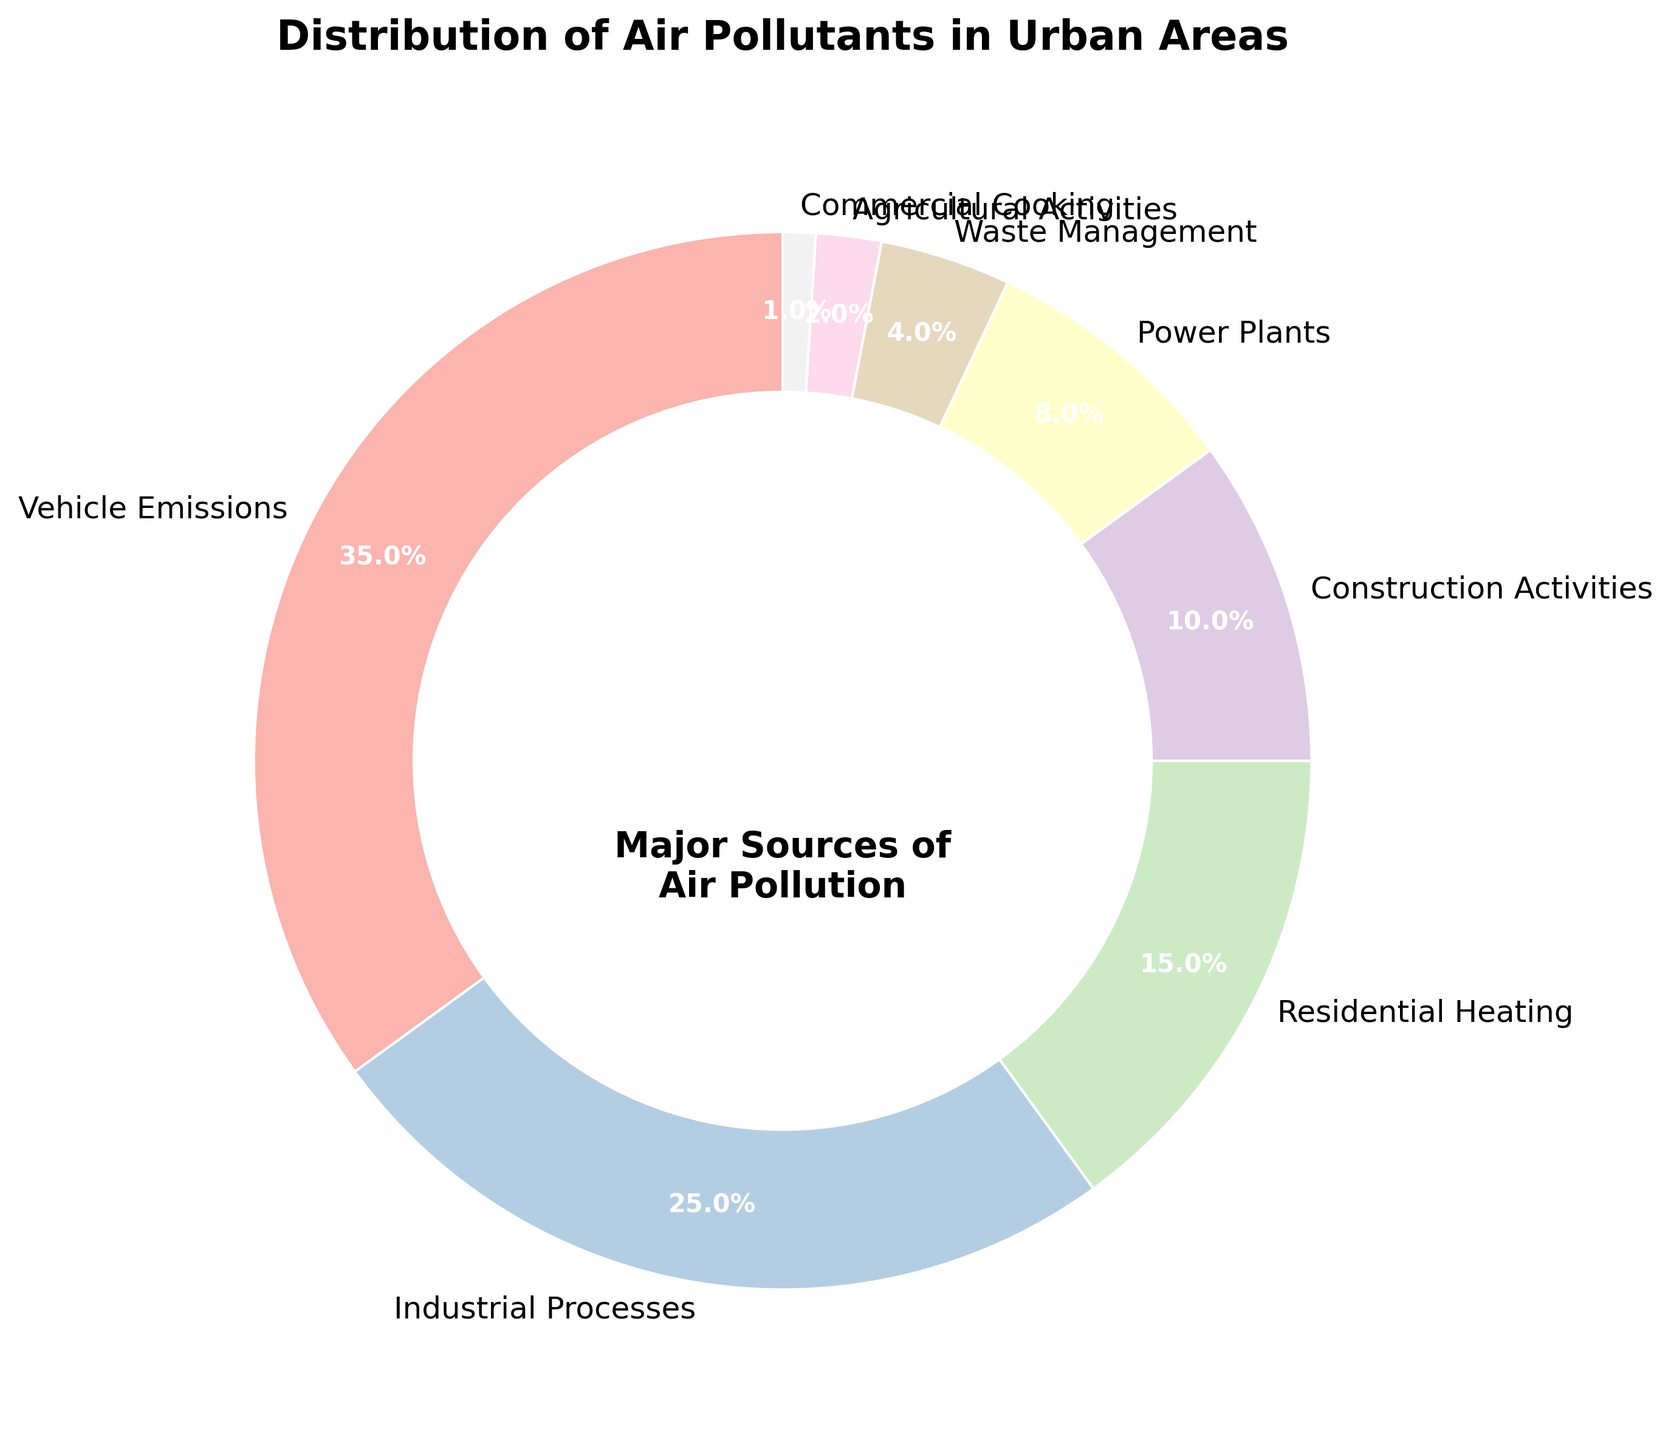Which source contributes the largest percentage to air pollution in urban areas? Observing the pie chart, the wedge labeled "Vehicle Emissions" is the largest, indicating it has the highest percentage.
Answer: Vehicle Emissions What is the combined percentage of air pollution from Industrial Processes and Residential Heating? Industrial Processes contributes 25%, and Residential Heating contributes 15%. Adding these percentages together: 25% + 15% = 40%.
Answer: 40% Is the percentage of air pollution from Construction Activities greater than that from Power Plants? The pie chart shows Construction Activities contributing 10% and Power Plants contributing 8%. Since 10% is greater than 8%, Construction Activities has a higher contribution.
Answer: Yes What percentage of air pollution is attributed to sources other than Vehicle Emissions, Industrial Processes, and Residential Heating? Adding the percentages of Vehicle Emissions, Industrial Processes, and Residential Heating: 35% + 25% + 15% = 75%. The total percentage must be 100%, so other sources contribute 100% - 75% = 25%.
Answer: 25% Which three sources have the smallest contributions to air pollution, and what are their combined percentages? The three smallest wedges are labeled Commercial Cooking (1%), Agricultural Activities (2%), and Waste Management (4%). Adding these together: 1% + 2% + 4% = 7%.
Answer: Commercial Cooking, Agricultural Activities, Waste Management; 7% How does the percentage of air pollution from Waste Management compare to that from Power Plants? The chart shows Waste Management at 4% and Power Plants at 8%. Since 4% is less than 8%, Waste Management contributes less.
Answer: Waste Management < Power Plants What is the difference in the percentage of air pollution between the largest and smallest sources? The largest source, Vehicle Emissions, contributes 35%, and the smallest source, Commercial Cooking, contributes 1%. The difference between these percentages is 35% - 1% = 34%.
Answer: 34% Is the sum of the percentages from Industrial Processes and Power Plants greater than from Construction Activities and Residential Heating? Industrial Processes (25%) + Power Plants (8%) = 33%. Construction Activities (10%) + Residential Heating (15%) = 25%. Comparing these sums, 33% is greater than 25%.
Answer: Yes 